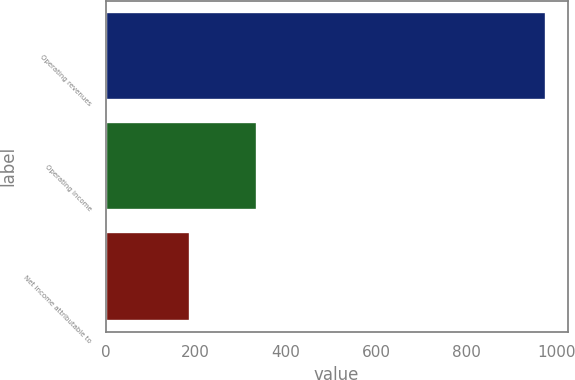<chart> <loc_0><loc_0><loc_500><loc_500><bar_chart><fcel>Operating revenues<fcel>Operating income<fcel>Net income attributable to<nl><fcel>976<fcel>335<fcel>187<nl></chart> 